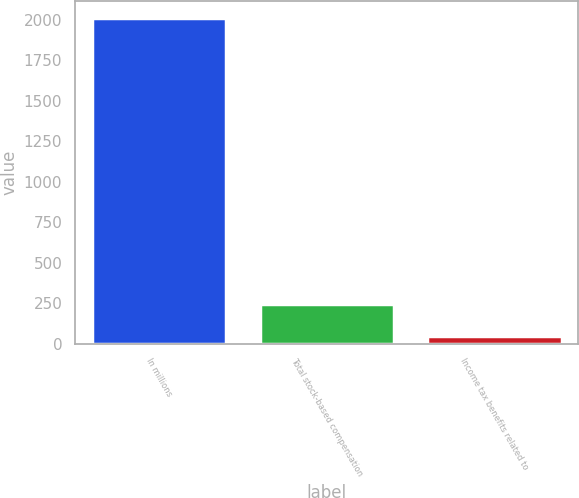Convert chart. <chart><loc_0><loc_0><loc_500><loc_500><bar_chart><fcel>In millions<fcel>Total stock-based compensation<fcel>Income tax benefits related to<nl><fcel>2012<fcel>244.4<fcel>48<nl></chart> 